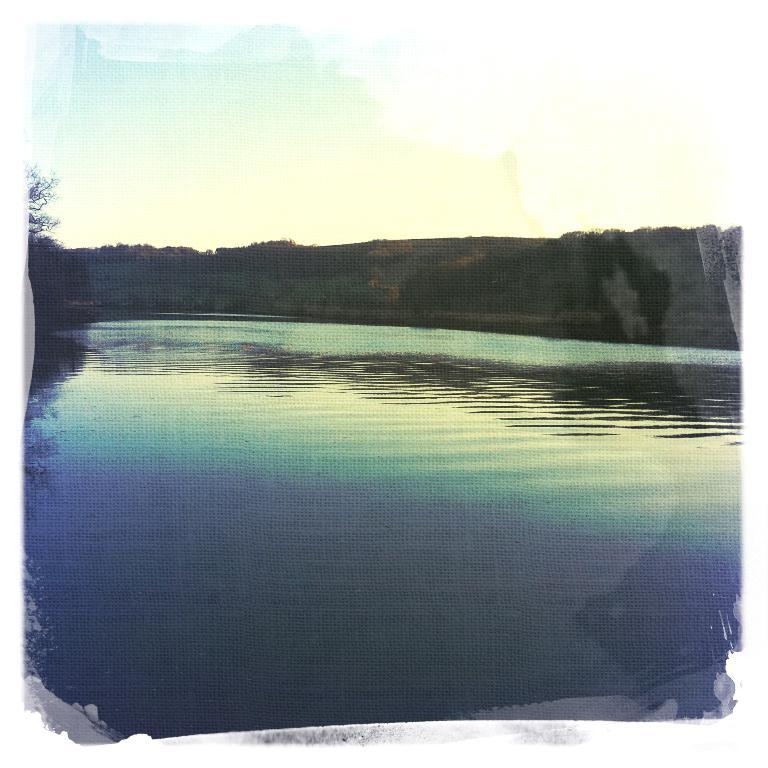What type of natural body of water is present in the image? There is a lake in the image. What type of vegetation can be seen in the image? There are trees in the image. What geological feature is visible in the background of the image? There is a rock in the background of the image. What is visible in the background of the image? The sky is visible in the background of the image. What type of sail can be seen on the lake in the image? There is no sail present on the lake in the image. What type of teeth can be seen in the image? There are no teeth visible in the image, as it features a lake, trees, a rock, and the sky. 